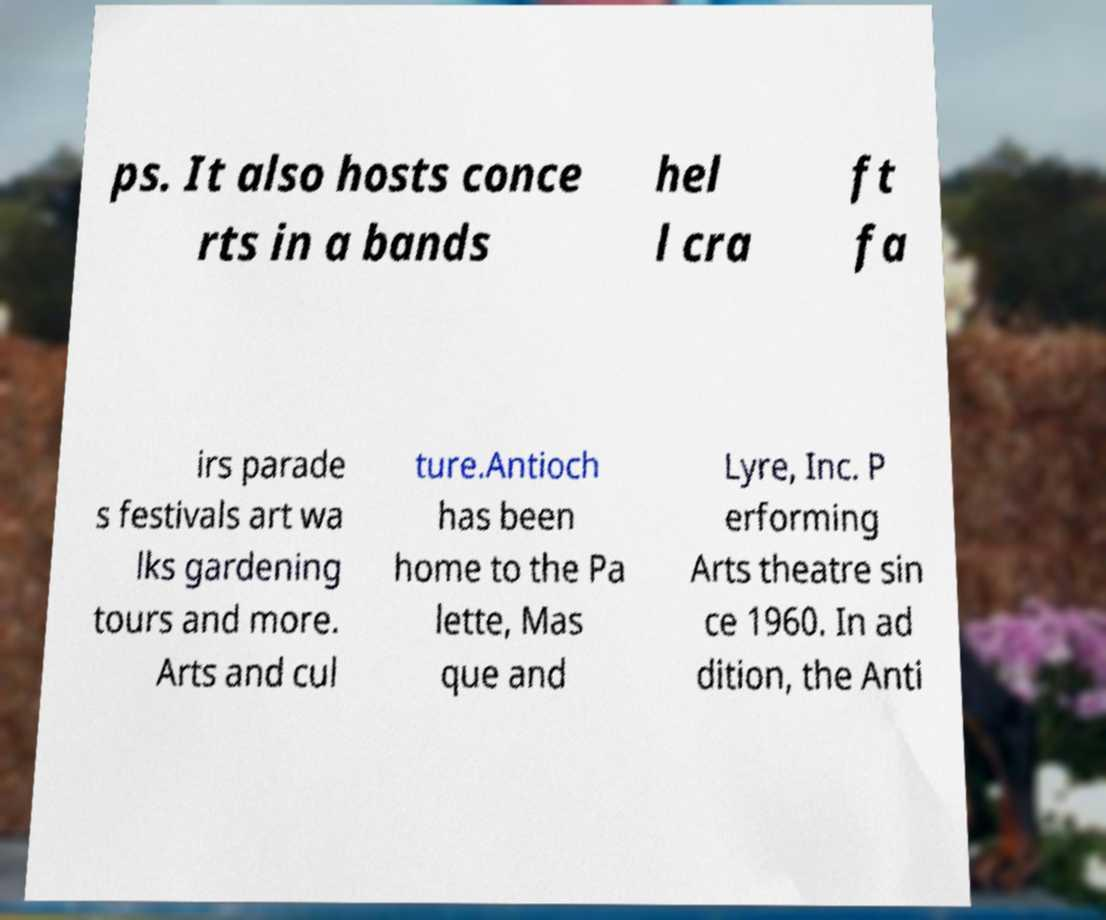There's text embedded in this image that I need extracted. Can you transcribe it verbatim? ps. It also hosts conce rts in a bands hel l cra ft fa irs parade s festivals art wa lks gardening tours and more. Arts and cul ture.Antioch has been home to the Pa lette, Mas que and Lyre, Inc. P erforming Arts theatre sin ce 1960. In ad dition, the Anti 